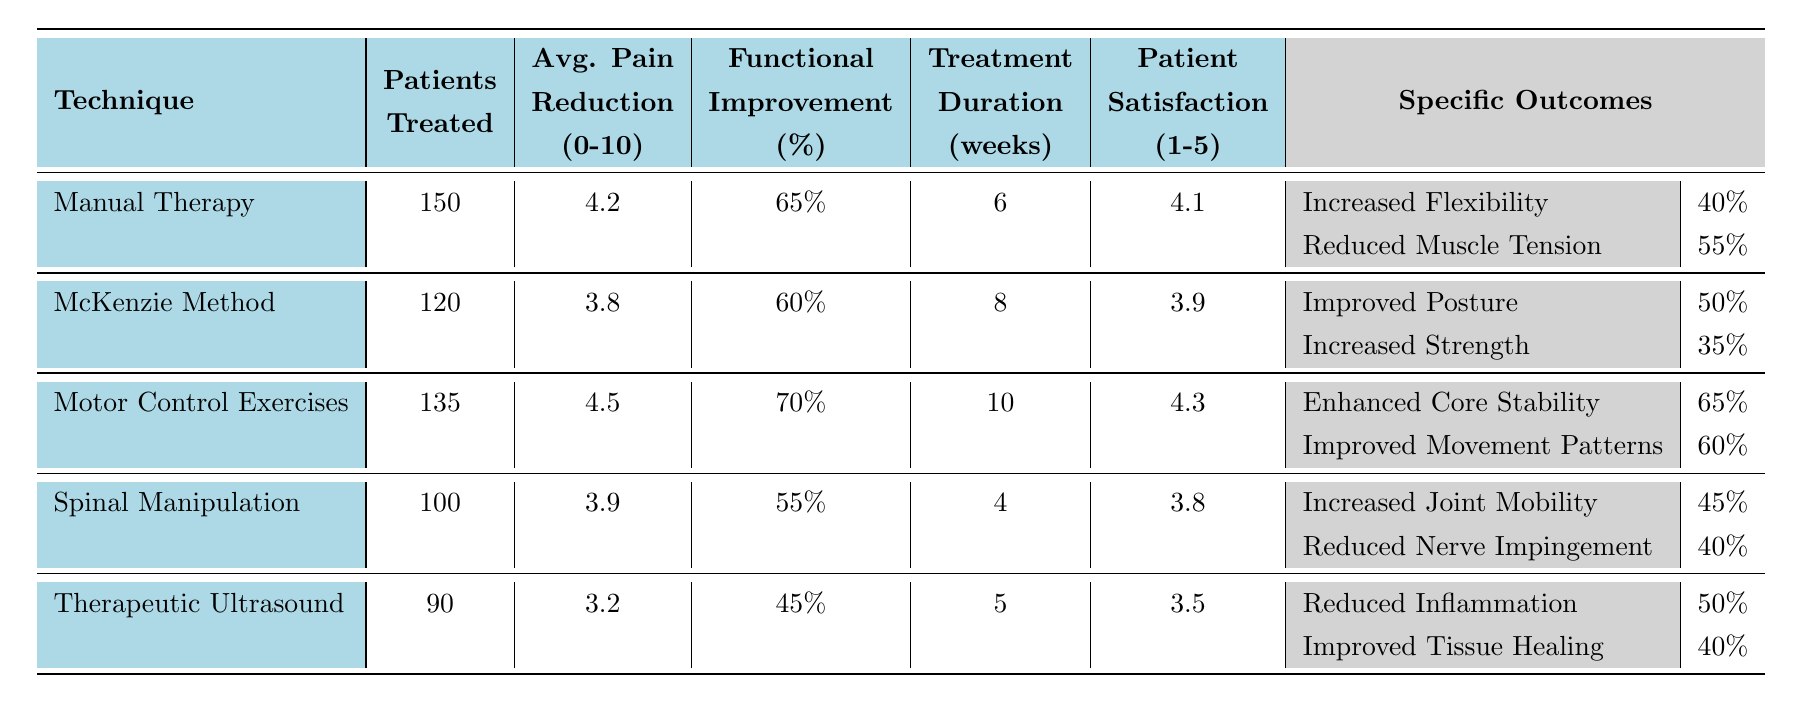What is the average pain reduction for the "Motor Control Exercises" technique? The table shows that the average pain reduction for "Motor Control Exercises" is listed as 4.5 on a 0-10 scale.
Answer: 4.5 How many patients were treated with "Therapeutic Ultrasound"? The number of patients treated with "Therapeutic Ultrasound" is indicated as 90 in the table.
Answer: 90 Which technique has the highest patient satisfaction rating? Comparing the patient satisfaction ratings: Manual Therapy (4.1), McKenzie Method (3.9), Motor Control Exercises (4.3), Spinal Manipulation (3.8), and Therapeutic Ultrasound (3.5), "Motor Control Exercises" has the highest rating at 4.3.
Answer: Motor Control Exercises What is the total number of patients treated across all techniques? Adding the patients treated for each technique: 150 (Manual Therapy) + 120 (McKenzie Method) + 135 (Motor Control Exercises) + 100 (Spinal Manipulation) + 90 (Therapeutic Ultrasound) gives a total of 695 patients.
Answer: 695 What is the functional improvement percentage for "Spinal Manipulation"? The table states that the functional improvement percentage for "Spinal Manipulation" is 55%.
Answer: 55% Is the average pain reduction for "McKenzie Method" greater than or equal to 4? The average pain reduction for "McKenzie Method" is 3.8, which is less than 4, so the statement is false.
Answer: No Which physiotherapy technique has the lowest functional improvement percentage? "Therapeutic Ultrasound" has the lowest functional improvement percentage at 45%, compared to others like Manual Therapy (65%), McKenzie Method (60%), Motor Control Exercises (70%), and Spinal Manipulation (55%).
Answer: Therapeutic Ultrasound Calculate the difference in average pain reduction between "Manual Therapy" and "Therapeutic Ultrasound." The average pain reduction for "Manual Therapy" is 4.2 and for "Therapeutic Ultrasound" is 3.2. The difference is 4.2 - 3.2 = 1.0.
Answer: 1.0 What specific outcome shows the most improvement for "Motor Control Exercises"? Among the specific outcomes for "Motor Control Exercises", "Enhanced Core Stability" shows an improvement of 65%, which is the highest compared to the improvement of "Improved Movement Patterns" at 60%.
Answer: Enhanced Core Stability Which technique has the shortest treatment duration? The shortest treatment duration is for "Spinal Manipulation", lasting 4 weeks, in comparison to other techniques with longer durations.
Answer: Spinal Manipulation 